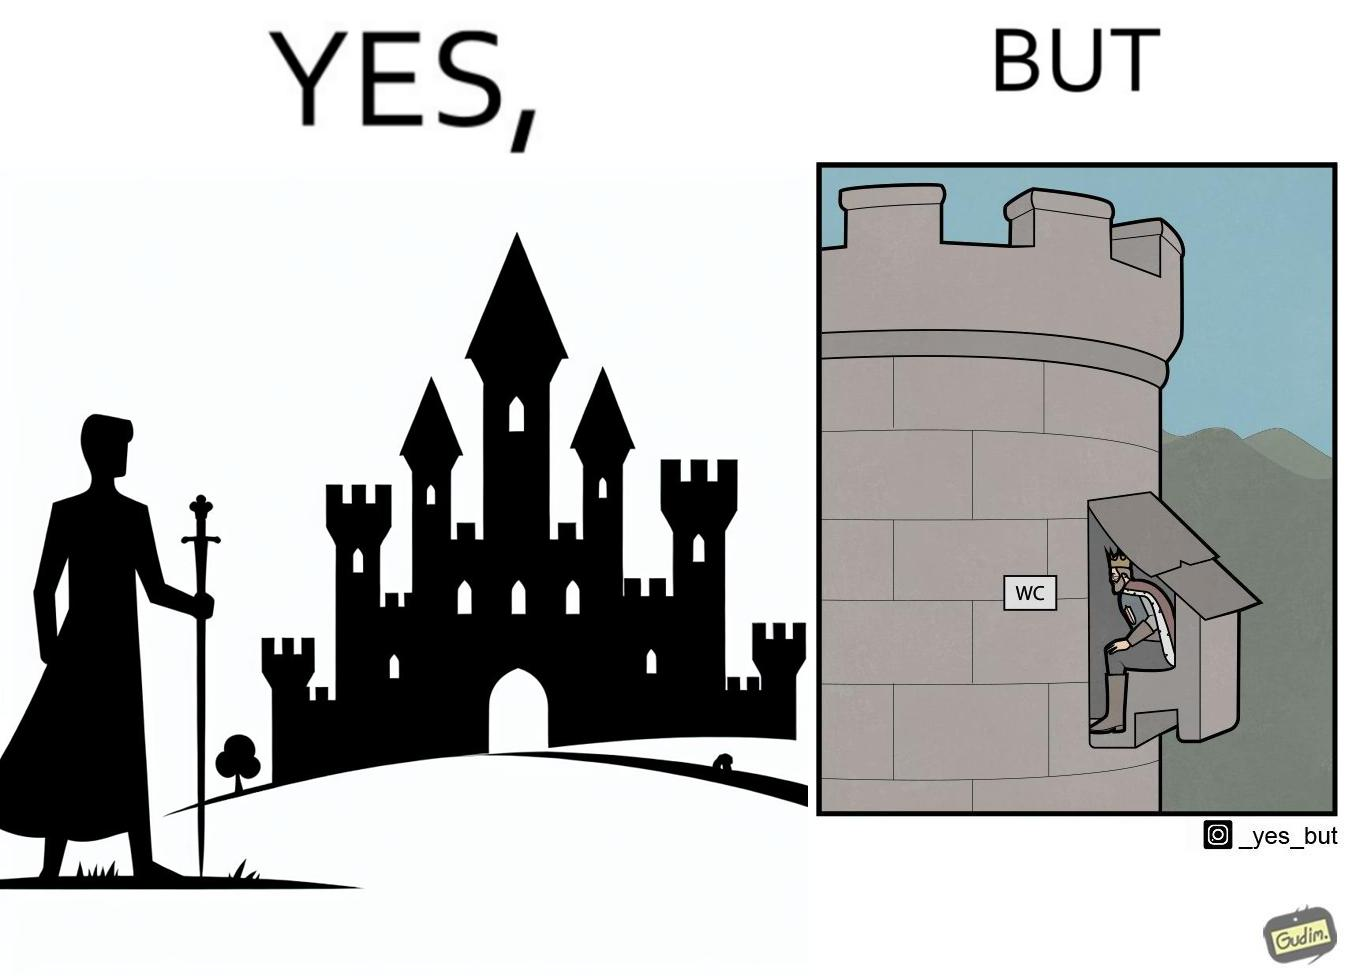What is the satirical meaning behind this image? The images are funny since it shows how even a mighty king must do simple things like using a toilet just like everyone else does 